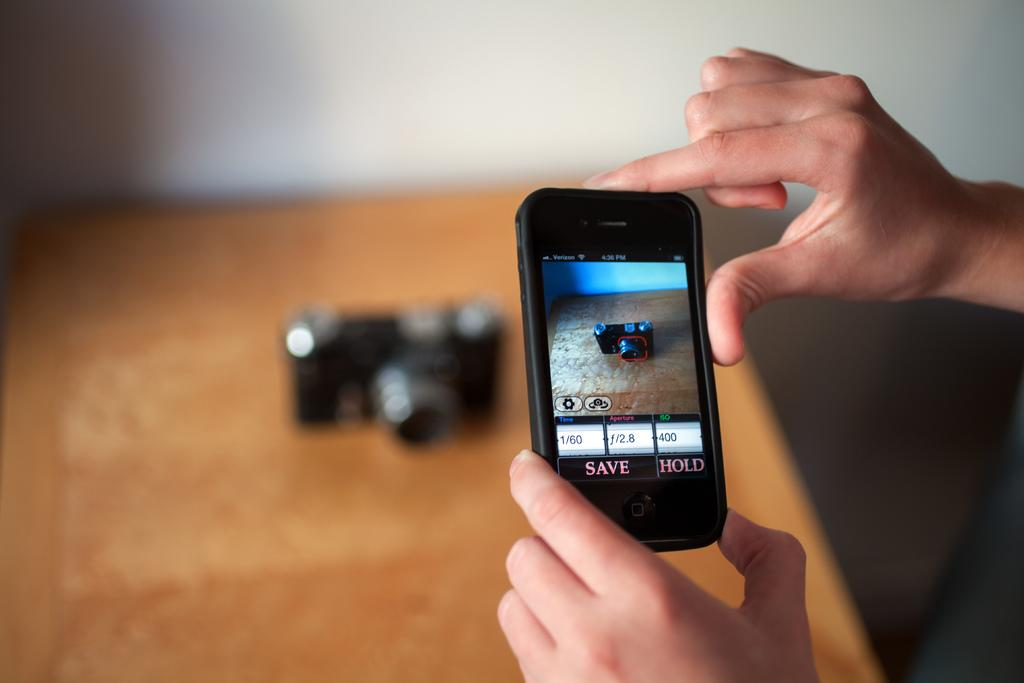Provide a one-sentence caption for the provided image. A phone's camera app has the option to save or hold the current image. 